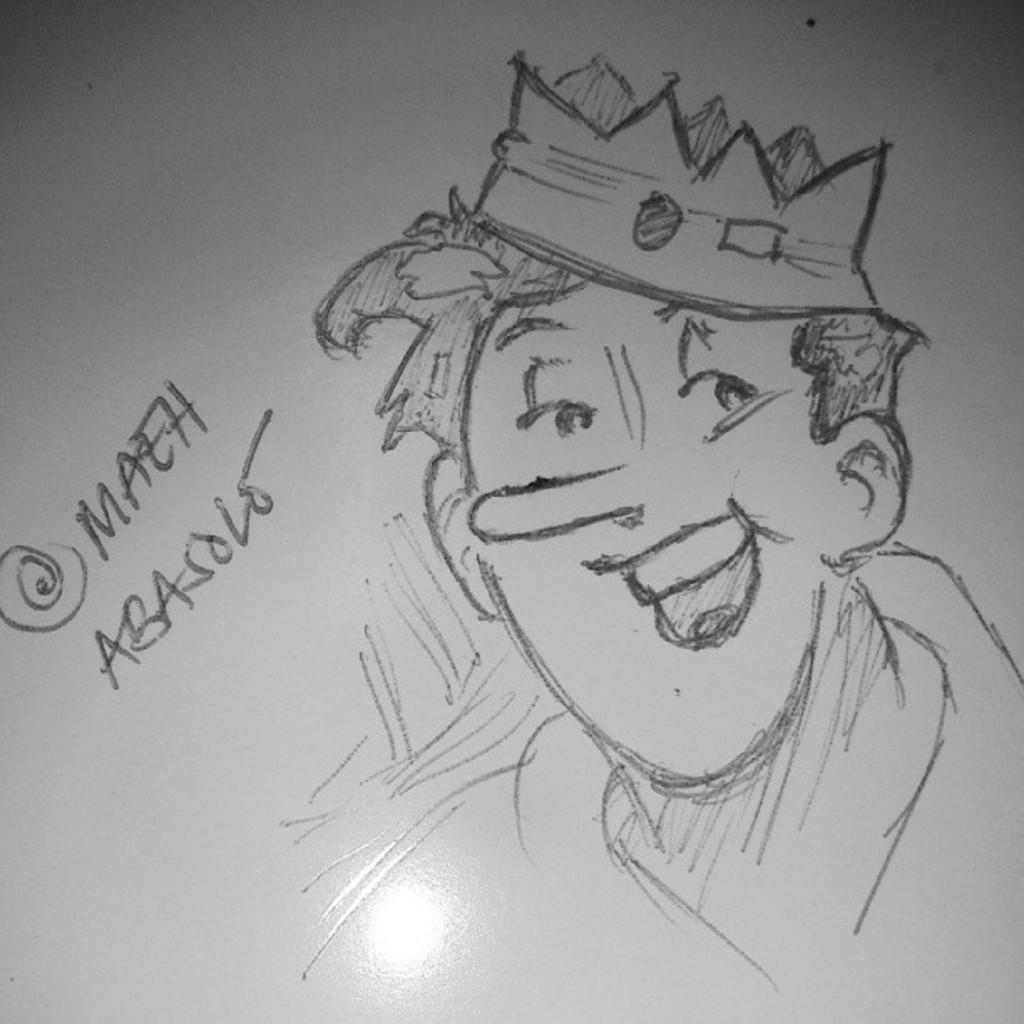What is depicted in the image? There is a sketch of a person in the image. What else is present in the image besides the sketch of the person? There is some text beside the person in the image. What type of book is the person holding in the image? There is no book present in the image; it features a sketch of a person with text beside them. What emotion or feeling is the person expressing in the image? The image does not depict the person expressing any specific emotion or feeling. 